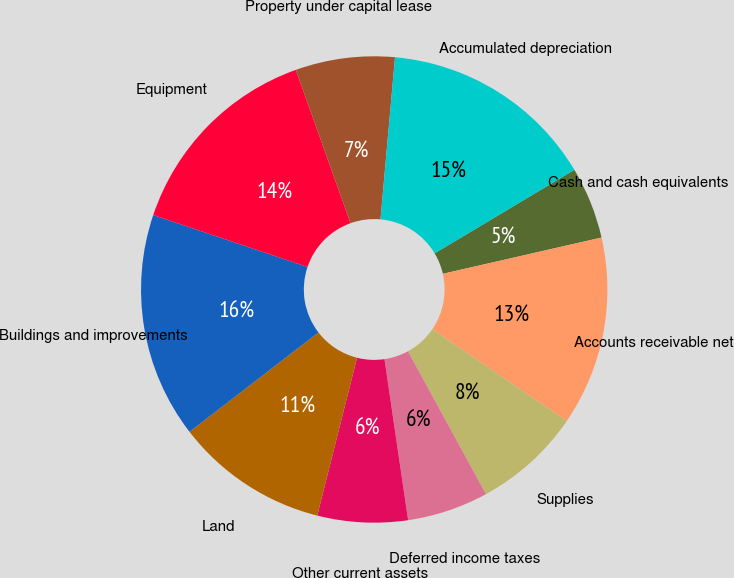Convert chart to OTSL. <chart><loc_0><loc_0><loc_500><loc_500><pie_chart><fcel>Cash and cash equivalents<fcel>Accounts receivable net<fcel>Supplies<fcel>Deferred income taxes<fcel>Other current assets<fcel>Land<fcel>Buildings and improvements<fcel>Equipment<fcel>Property under capital lease<fcel>Accumulated depreciation<nl><fcel>5.0%<fcel>13.12%<fcel>7.5%<fcel>5.63%<fcel>6.25%<fcel>10.62%<fcel>15.62%<fcel>14.37%<fcel>6.88%<fcel>15.0%<nl></chart> 